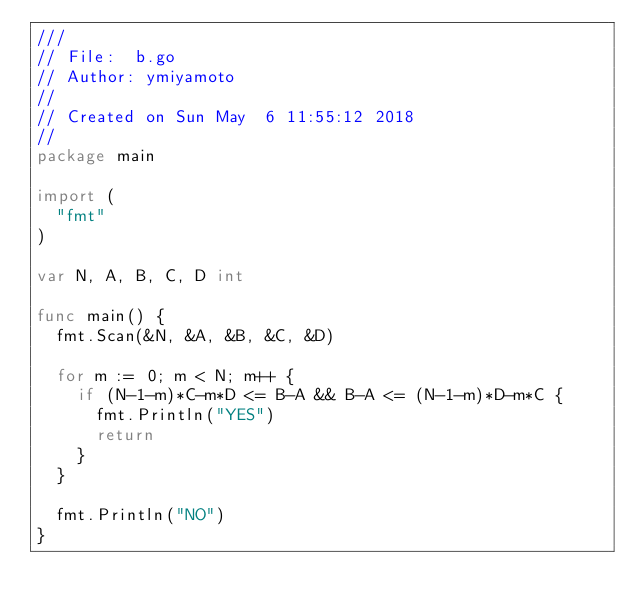Convert code to text. <code><loc_0><loc_0><loc_500><loc_500><_Go_>///
// File:  b.go
// Author: ymiyamoto
//
// Created on Sun May  6 11:55:12 2018
//
package main

import (
	"fmt"
)

var N, A, B, C, D int

func main() {
	fmt.Scan(&N, &A, &B, &C, &D)

	for m := 0; m < N; m++ {
		if (N-1-m)*C-m*D <= B-A && B-A <= (N-1-m)*D-m*C {
			fmt.Println("YES")
			return
		}
	}

	fmt.Println("NO")
}
</code> 